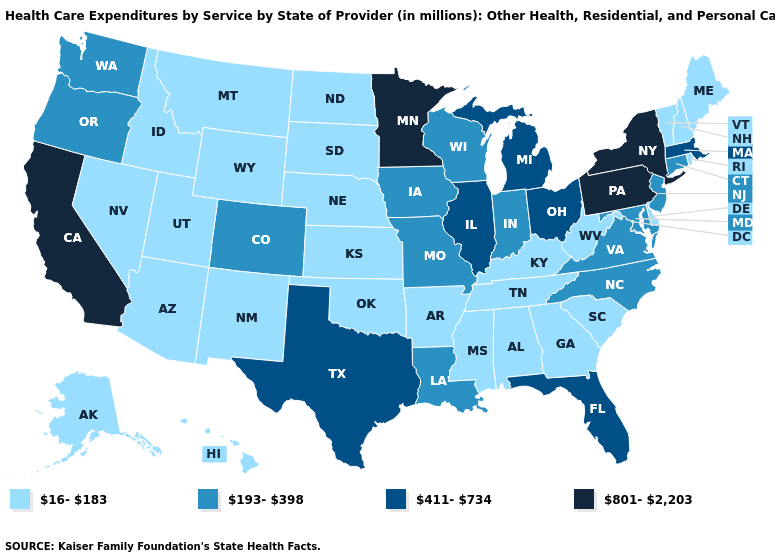Name the states that have a value in the range 16-183?
Give a very brief answer. Alabama, Alaska, Arizona, Arkansas, Delaware, Georgia, Hawaii, Idaho, Kansas, Kentucky, Maine, Mississippi, Montana, Nebraska, Nevada, New Hampshire, New Mexico, North Dakota, Oklahoma, Rhode Island, South Carolina, South Dakota, Tennessee, Utah, Vermont, West Virginia, Wyoming. What is the value of Idaho?
Give a very brief answer. 16-183. Does the map have missing data?
Short answer required. No. Which states have the highest value in the USA?
Concise answer only. California, Minnesota, New York, Pennsylvania. Name the states that have a value in the range 801-2,203?
Be succinct. California, Minnesota, New York, Pennsylvania. What is the highest value in the MidWest ?
Concise answer only. 801-2,203. What is the value of Maryland?
Be succinct. 193-398. Name the states that have a value in the range 801-2,203?
Quick response, please. California, Minnesota, New York, Pennsylvania. What is the highest value in the West ?
Be succinct. 801-2,203. What is the lowest value in the Northeast?
Quick response, please. 16-183. What is the value of Virginia?
Quick response, please. 193-398. Name the states that have a value in the range 16-183?
Answer briefly. Alabama, Alaska, Arizona, Arkansas, Delaware, Georgia, Hawaii, Idaho, Kansas, Kentucky, Maine, Mississippi, Montana, Nebraska, Nevada, New Hampshire, New Mexico, North Dakota, Oklahoma, Rhode Island, South Carolina, South Dakota, Tennessee, Utah, Vermont, West Virginia, Wyoming. Name the states that have a value in the range 193-398?
Concise answer only. Colorado, Connecticut, Indiana, Iowa, Louisiana, Maryland, Missouri, New Jersey, North Carolina, Oregon, Virginia, Washington, Wisconsin. What is the value of Oklahoma?
Write a very short answer. 16-183. Does North Carolina have the highest value in the USA?
Quick response, please. No. 